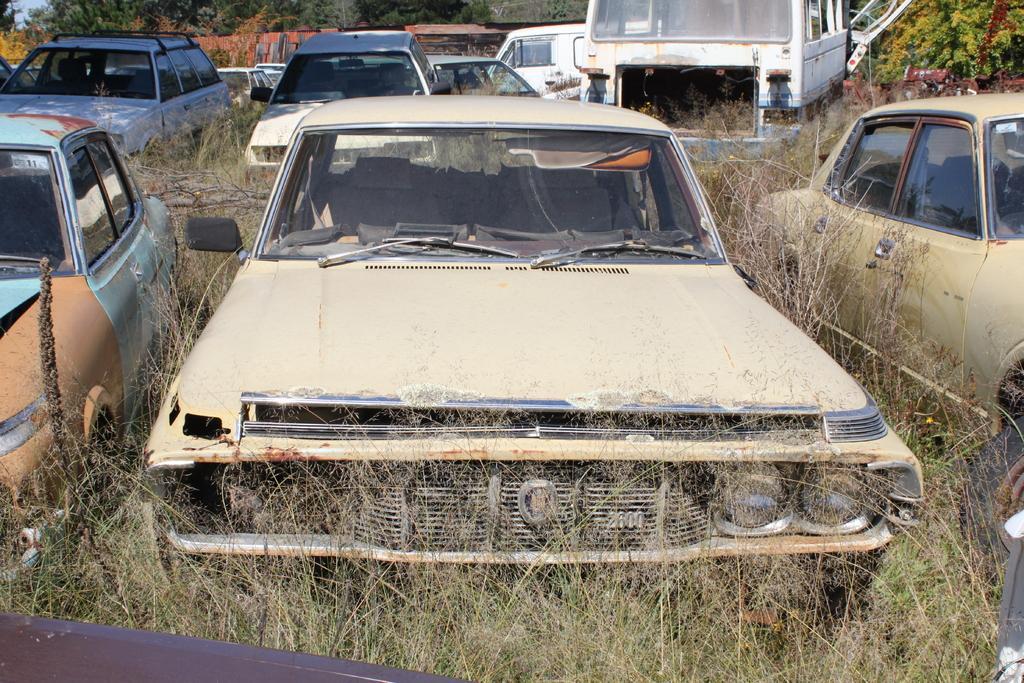Please provide a concise description of this image. In this picture we can see some vehicles parked on the path and behind the vehicles there are trees and grass. 